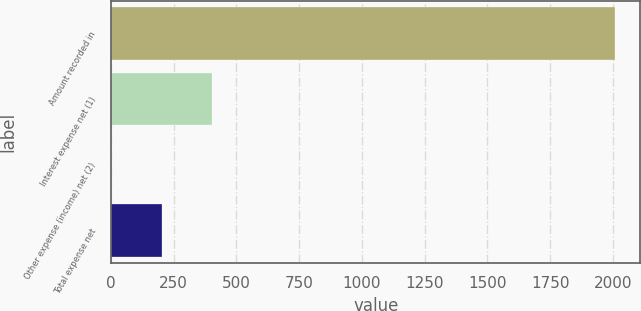<chart> <loc_0><loc_0><loc_500><loc_500><bar_chart><fcel>Amount recorded in<fcel>Interest expense net (1)<fcel>Other expense (income) net (2)<fcel>Total expense net<nl><fcel>2009<fcel>402.36<fcel>0.7<fcel>201.53<nl></chart> 